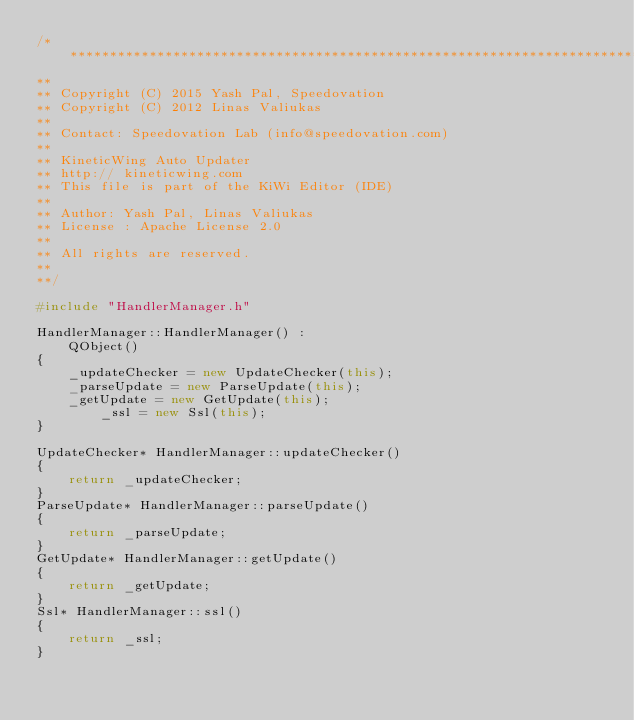Convert code to text. <code><loc_0><loc_0><loc_500><loc_500><_C++_>/****************************************************************************
**
** Copyright (C) 2015 Yash Pal, Speedovation
** Copyright (C) 2012 Linas Valiukas
**
** Contact: Speedovation Lab (info@speedovation.com)
**
** KineticWing Auto Updater
** http:// kineticwing.com
** This file is part of the KiWi Editor (IDE)
**
** Author: Yash Pal, Linas Valiukas
** License : Apache License 2.0
**
** All rights are reserved.
**
**/

#include "HandlerManager.h"

HandlerManager::HandlerManager() :
    QObject()
{
    _updateChecker = new UpdateChecker(this);
    _parseUpdate = new ParseUpdate(this);
    _getUpdate = new GetUpdate(this);
        _ssl = new Ssl(this);
}

UpdateChecker* HandlerManager::updateChecker()
{
    return _updateChecker;
}
ParseUpdate* HandlerManager::parseUpdate()
{
    return _parseUpdate;
}
GetUpdate* HandlerManager::getUpdate()
{
    return _getUpdate;
}
Ssl* HandlerManager::ssl()
{
    return _ssl;
}
</code> 